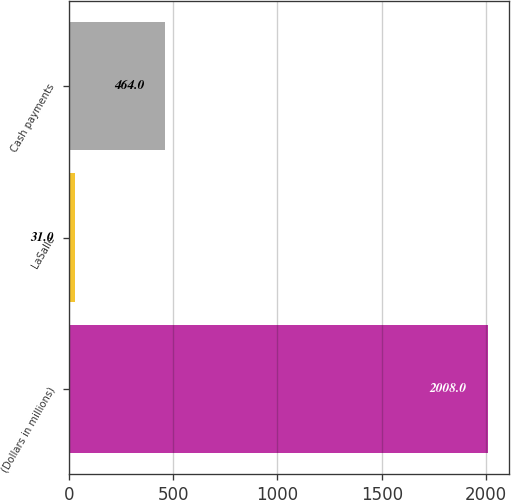Convert chart. <chart><loc_0><loc_0><loc_500><loc_500><bar_chart><fcel>(Dollars in millions)<fcel>LaSalle<fcel>Cash payments<nl><fcel>2008<fcel>31<fcel>464<nl></chart> 